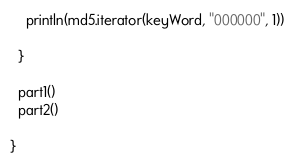Convert code to text. <code><loc_0><loc_0><loc_500><loc_500><_Scala_>    println(md5.iterator(keyWord, "000000", 1))

  }

  part1()
  part2()

}
</code> 